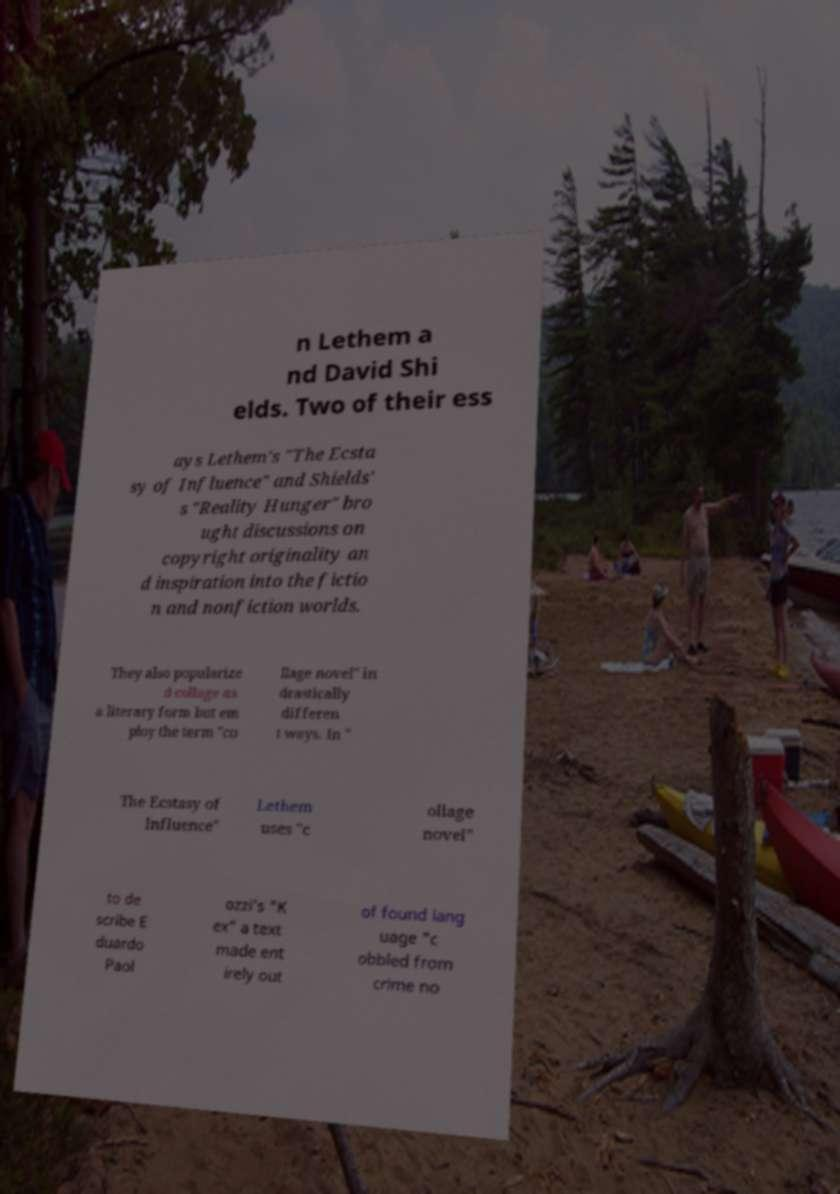What messages or text are displayed in this image? I need them in a readable, typed format. n Lethem a nd David Shi elds. Two of their ess ays Lethem's "The Ecsta sy of Influence" and Shields' s "Reality Hunger" bro ught discussions on copyright originality an d inspiration into the fictio n and nonfiction worlds. They also popularize d collage as a literary form but em ploy the term "co llage novel" in drastically differen t ways. In " The Ecstasy of Influence" Lethem uses "c ollage novel" to de scribe E duardo Paol ozzi's "K ex" a text made ent irely out of found lang uage "c obbled from crime no 